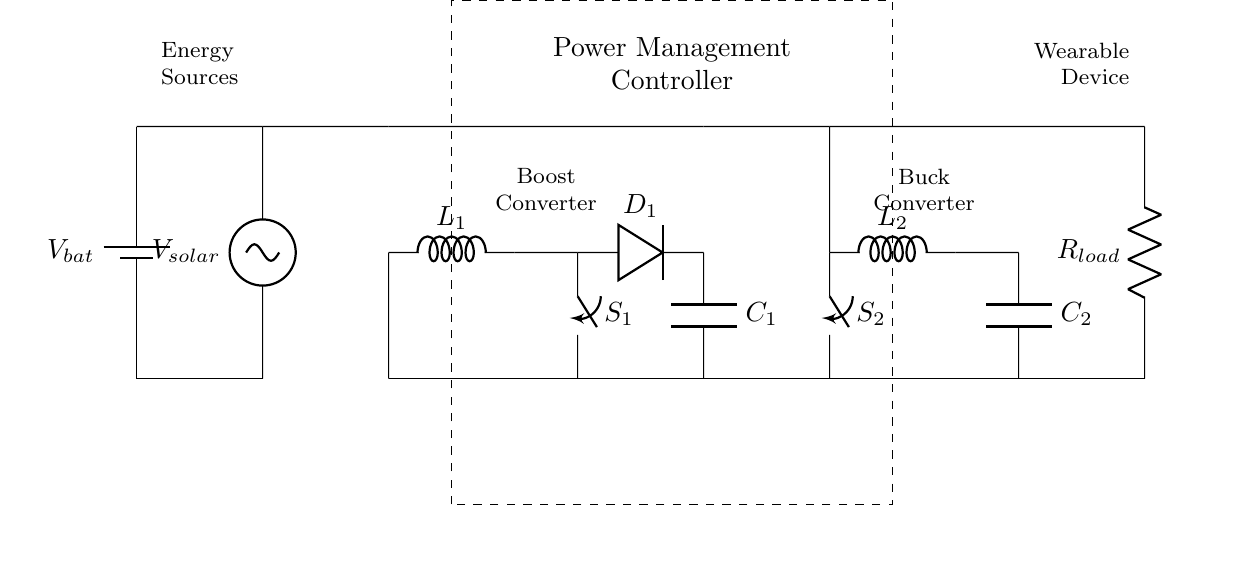What is the primary energy source used in this circuit? The primary energy source is the battery, labeled as V_bat, and it provides direct power to the circuit.
Answer: battery What component is responsible for increasing voltage within the circuit? The component responsible for increasing voltage is the boost converter, which includes an inductor (L1), a diode (D1), and a switch (S1) to step up the voltage from the battery or solar sources.
Answer: boost converter How many energy sources are present in the circuit? There are two energy sources depicted which are the battery and the solar cell, indicating dual input options for power supply.
Answer: two What is the load in this circuit? The load in the circuit is represented by R_load, which indicates the impedance that the device powers as its main work or function.
Answer: R_load Which component serves to regulate the outgoing voltage? The buck converter regulates the outgoing voltage, stepping down the voltage for safe distribution to the wearable device while stabilizing output levels.
Answer: buck converter Does this circuit utilize solar energy? Yes, the circuit utilizes solar energy, as indicated by the presence of the solar cell labeled V_solar which provides an additional energy input.
Answer: yes What is the role of the power management controller in the circuit? The power management controller orchestrates the operation of the boost and buck converters for optimal switching between energy sources and load management, ensuring efficiency and prolonging battery life.
Answer: regulates power 